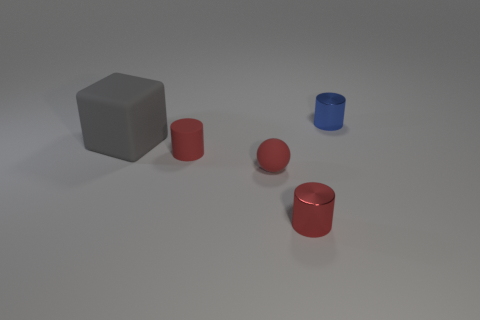There is a metallic thing that is behind the rubber cylinder that is to the right of the big thing; how big is it?
Keep it short and to the point. Small. There is a shiny thing in front of the red matte sphere; is its color the same as the rubber ball that is left of the small blue metallic object?
Make the answer very short. Yes. What number of large gray rubber objects are right of the small red cylinder on the left side of the tiny metal cylinder that is in front of the blue metallic cylinder?
Offer a terse response. 0. What number of objects are in front of the tiny blue cylinder and on the right side of the big matte cube?
Provide a succinct answer. 3. Are there more blue metallic cylinders that are to the left of the tiny blue object than large blue cubes?
Ensure brevity in your answer.  No. What number of matte cubes have the same size as the ball?
Give a very brief answer. 0. What size is the matte thing that is the same color as the matte cylinder?
Keep it short and to the point. Small. How many large things are either blue shiny things or matte spheres?
Offer a very short reply. 0. What number of small red metallic cylinders are there?
Keep it short and to the point. 1. Are there the same number of gray objects behind the gray block and large things to the right of the tiny red shiny object?
Give a very brief answer. Yes. 